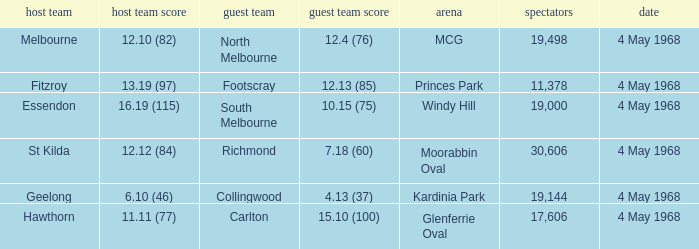How big was the crowd of the team that scored 4.13 (37)? 19144.0. 